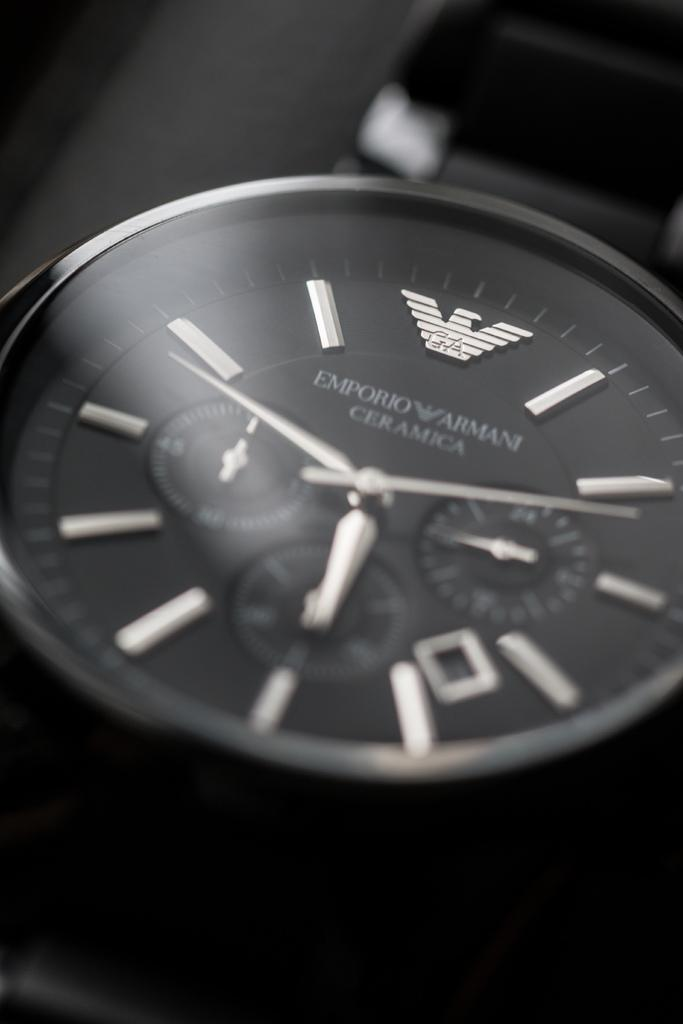<image>
Render a clear and concise summary of the photo. The face of a black watch made by Emporio Armani 